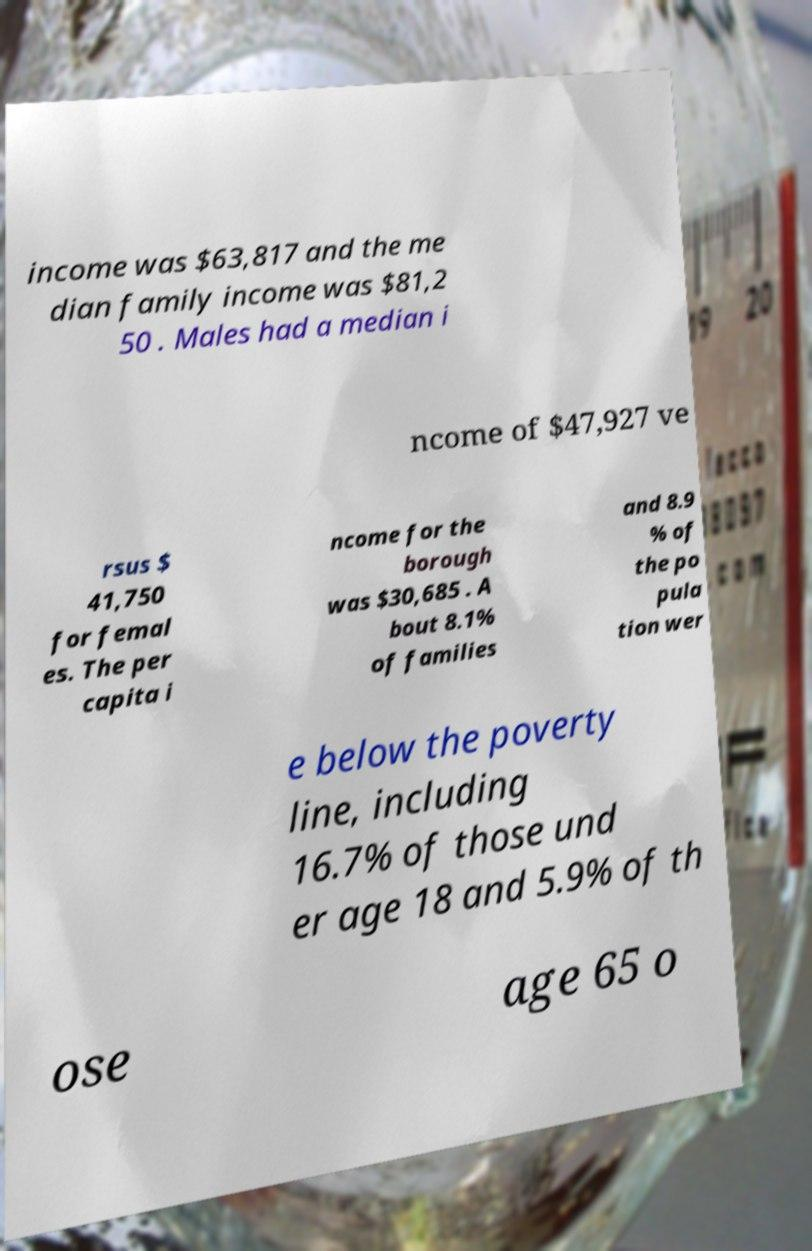Can you accurately transcribe the text from the provided image for me? income was $63,817 and the me dian family income was $81,2 50 . Males had a median i ncome of $47,927 ve rsus $ 41,750 for femal es. The per capita i ncome for the borough was $30,685 . A bout 8.1% of families and 8.9 % of the po pula tion wer e below the poverty line, including 16.7% of those und er age 18 and 5.9% of th ose age 65 o 